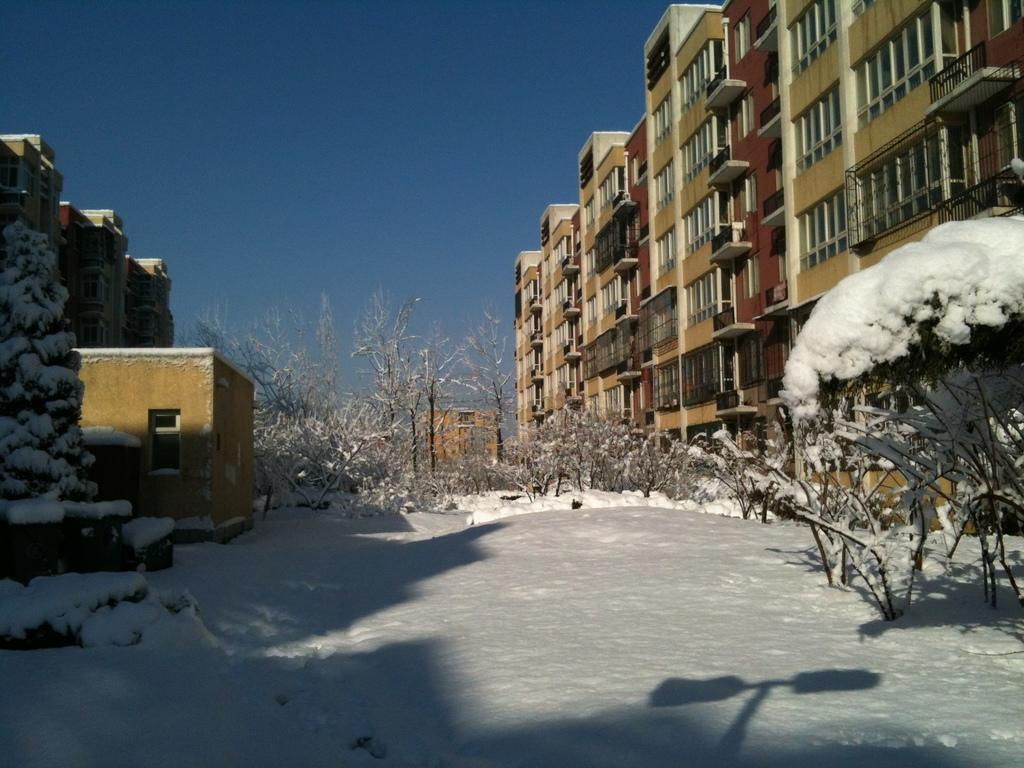What type of structures can be seen in the image? There are buildings in the image. What feature is visible on the buildings? There are windows visible in the image. What type of vegetation is present in the image? There are trees in the image. What weather condition is depicted in the image? There is snow in the image. What color is the sky in the image? The sky is blue in the image. What type of list can be seen in the image? There is no list present in the image. Does the existence of snow in the image prove the existence of a snowman? The presence of snow in the image does not prove the existence of a snowman, as there is no snowman depicted. 